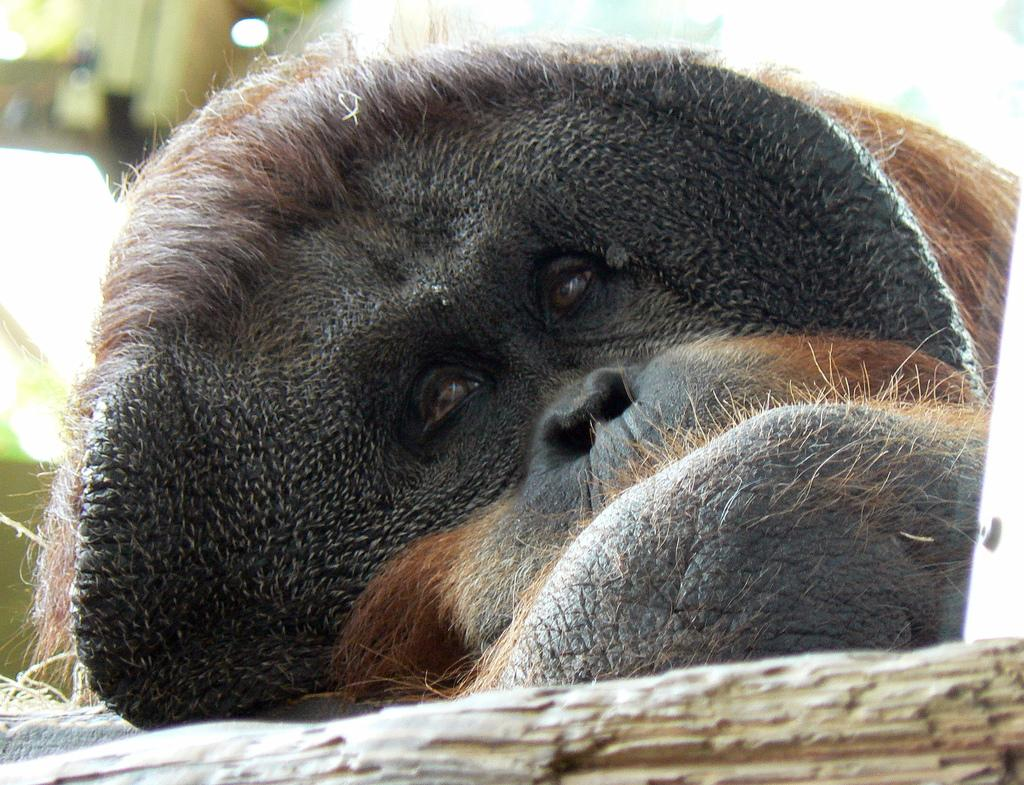What type of animal is in the image? There is a chimpanzee in the image. What is the chimpanzee doing in the image? The chimpanzee is lying on a surface in the image. Where is the chimpanzee located in the image? The chimpanzee is in the middle of the image. What type of cheese is the chimpanzee eating in the image? There is no cheese present in the image, and the chimpanzee is not eating anything. How many ladybugs can be seen on the chimpanzee in the image? There are no ladybugs present in the image, and the chimpanzee is not interacting with any ladybugs. 